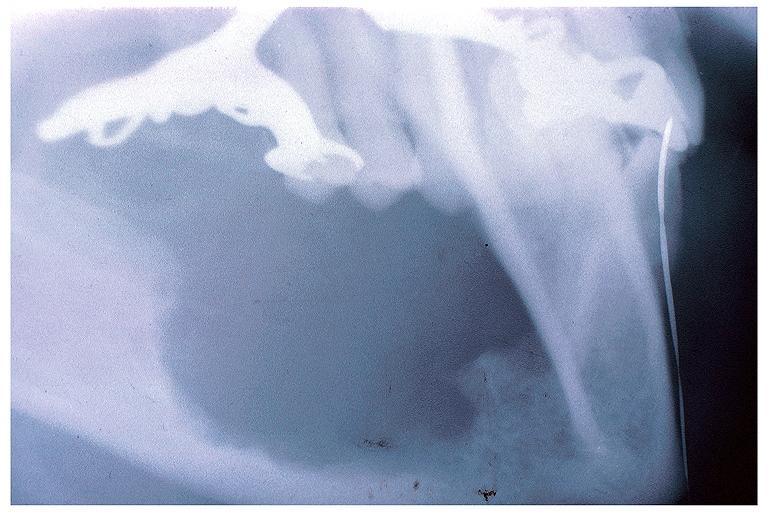what is present?
Answer the question using a single word or phrase. Oral 